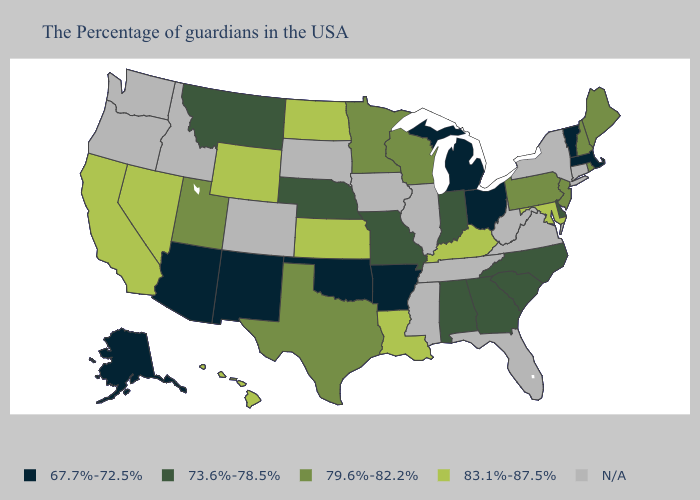What is the value of Wyoming?
Write a very short answer. 83.1%-87.5%. Does Utah have the lowest value in the USA?
Give a very brief answer. No. What is the lowest value in the MidWest?
Quick response, please. 67.7%-72.5%. Does the first symbol in the legend represent the smallest category?
Give a very brief answer. Yes. What is the value of Oregon?
Short answer required. N/A. Name the states that have a value in the range 79.6%-82.2%?
Write a very short answer. Maine, Rhode Island, New Hampshire, New Jersey, Pennsylvania, Wisconsin, Minnesota, Texas, Utah. Which states have the highest value in the USA?
Short answer required. Maryland, Kentucky, Louisiana, Kansas, North Dakota, Wyoming, Nevada, California, Hawaii. What is the value of Alabama?
Write a very short answer. 73.6%-78.5%. Among the states that border Nevada , does Arizona have the lowest value?
Write a very short answer. Yes. Name the states that have a value in the range 73.6%-78.5%?
Keep it brief. Delaware, North Carolina, South Carolina, Georgia, Indiana, Alabama, Missouri, Nebraska, Montana. What is the value of New Mexico?
Short answer required. 67.7%-72.5%. What is the value of Idaho?
Give a very brief answer. N/A. Does Kansas have the highest value in the MidWest?
Concise answer only. Yes. Name the states that have a value in the range 73.6%-78.5%?
Write a very short answer. Delaware, North Carolina, South Carolina, Georgia, Indiana, Alabama, Missouri, Nebraska, Montana. Does Alabama have the highest value in the South?
Give a very brief answer. No. 